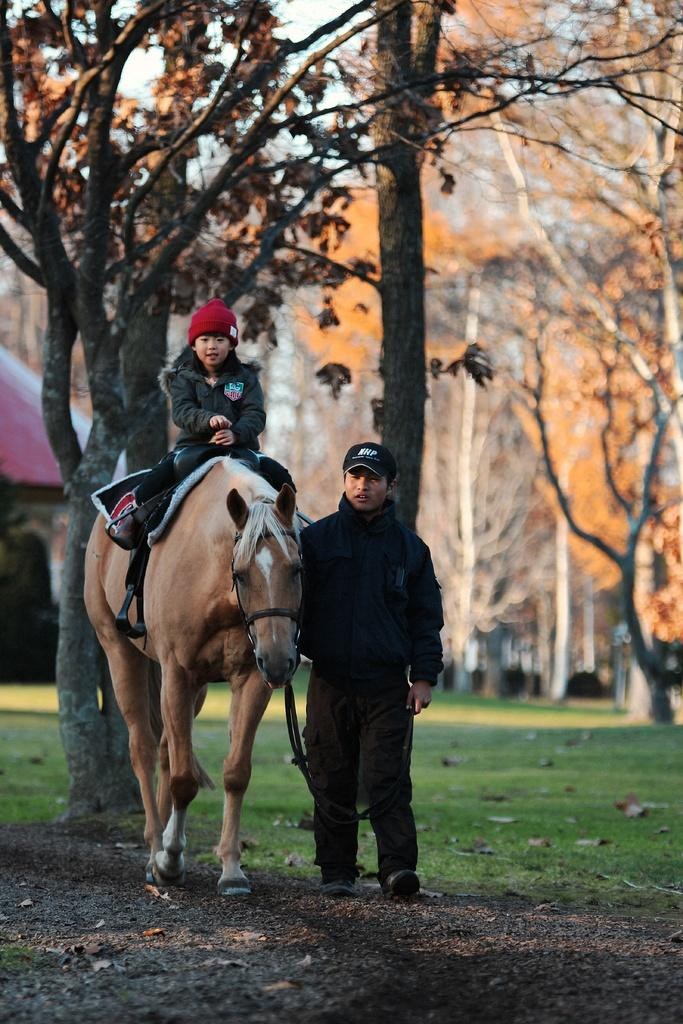Who is the main subject in the image? There is a girl in the image. What is the girl doing in the image? The girl is sitting on a horse. Who else is present in the image? There is a man in the image. What is the man doing in the image? The man is holding the horse. What can be seen in the background of the image? There are trees in the background of the image. Where is the shop located in the image? There is no shop present in the image. What type of mask is the girl wearing in the image? The girl is not wearing a mask in the image. 